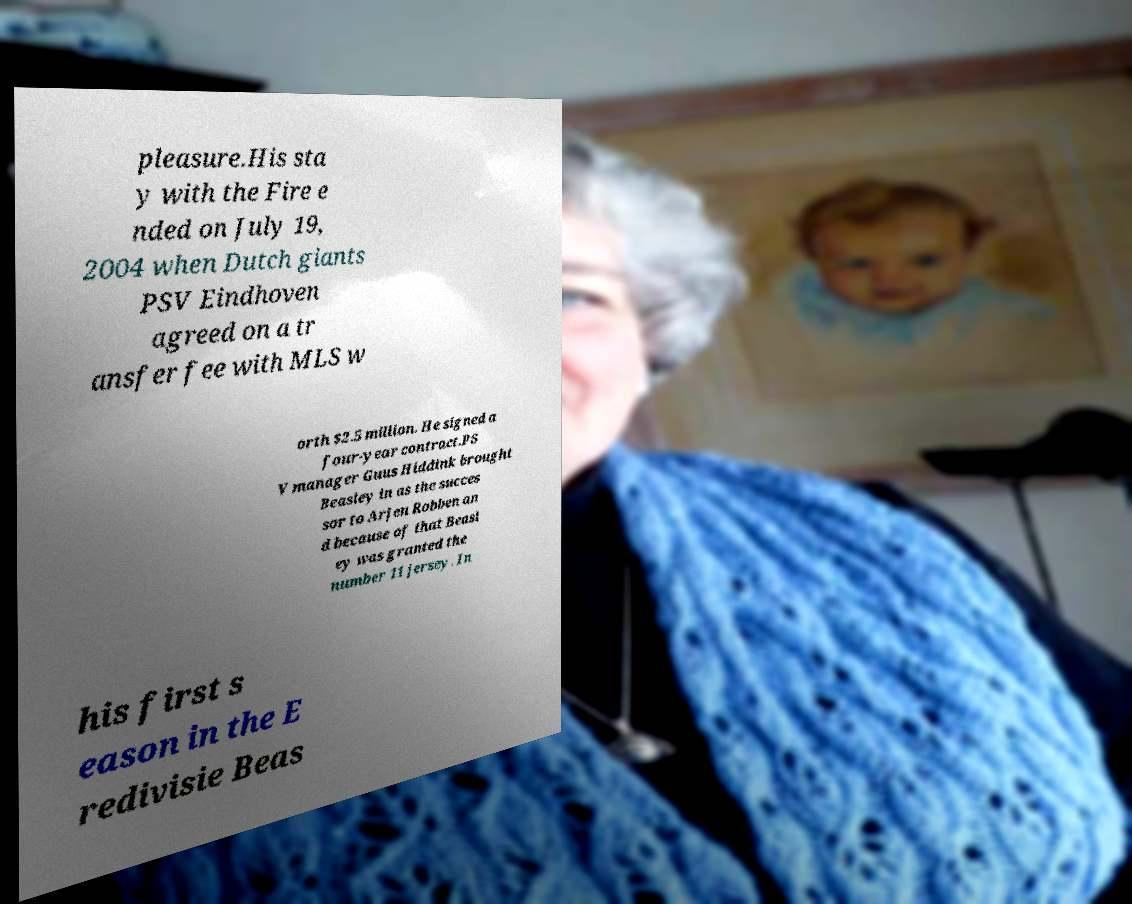There's text embedded in this image that I need extracted. Can you transcribe it verbatim? pleasure.His sta y with the Fire e nded on July 19, 2004 when Dutch giants PSV Eindhoven agreed on a tr ansfer fee with MLS w orth $2.5 million. He signed a four-year contract.PS V manager Guus Hiddink brought Beasley in as the succes sor to Arjen Robben an d because of that Beasl ey was granted the number 11 jersey. In his first s eason in the E redivisie Beas 